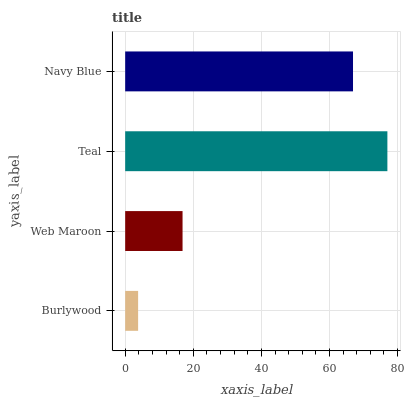Is Burlywood the minimum?
Answer yes or no. Yes. Is Teal the maximum?
Answer yes or no. Yes. Is Web Maroon the minimum?
Answer yes or no. No. Is Web Maroon the maximum?
Answer yes or no. No. Is Web Maroon greater than Burlywood?
Answer yes or no. Yes. Is Burlywood less than Web Maroon?
Answer yes or no. Yes. Is Burlywood greater than Web Maroon?
Answer yes or no. No. Is Web Maroon less than Burlywood?
Answer yes or no. No. Is Navy Blue the high median?
Answer yes or no. Yes. Is Web Maroon the low median?
Answer yes or no. Yes. Is Burlywood the high median?
Answer yes or no. No. Is Teal the low median?
Answer yes or no. No. 